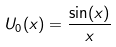<formula> <loc_0><loc_0><loc_500><loc_500>U _ { 0 } ( x ) = \frac { \sin ( x ) } { x }</formula> 